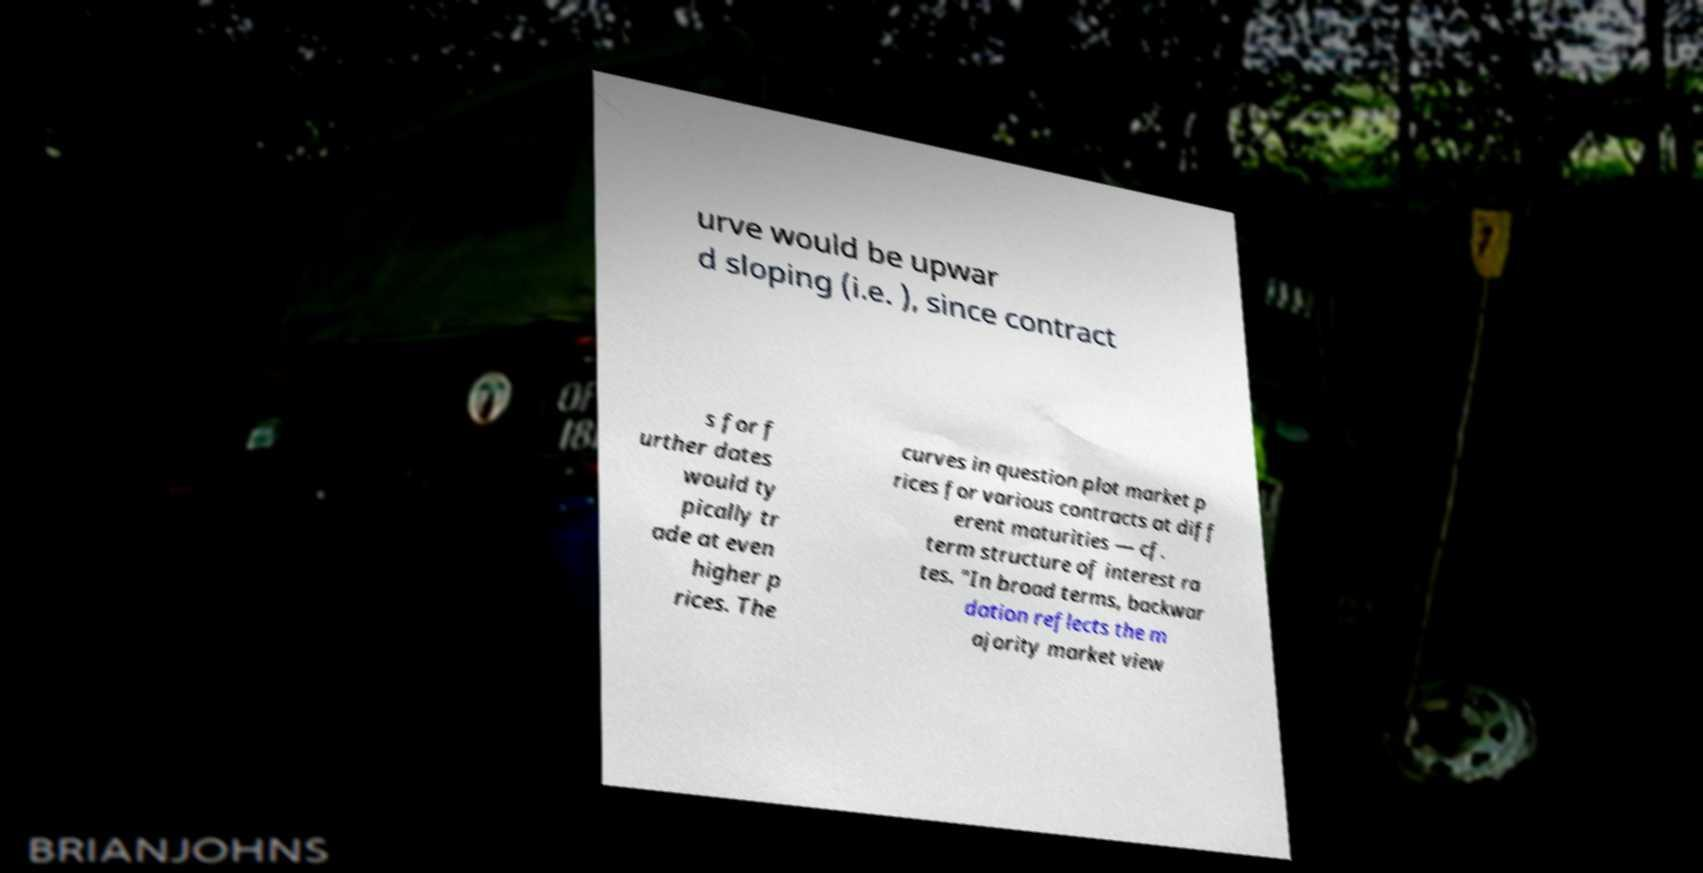Please read and relay the text visible in this image. What does it say? urve would be upwar d sloping (i.e. ), since contract s for f urther dates would ty pically tr ade at even higher p rices. The curves in question plot market p rices for various contracts at diff erent maturities — cf. term structure of interest ra tes. "In broad terms, backwar dation reflects the m ajority market view 